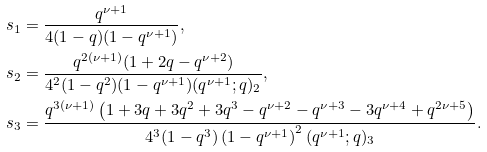Convert formula to latex. <formula><loc_0><loc_0><loc_500><loc_500>s _ { 1 } & = \frac { q ^ { \nu + 1 } } { 4 ( 1 - q ) ( 1 - q ^ { \nu + 1 } ) } , \\ s _ { 2 } & = \frac { q ^ { 2 ( \nu + 1 ) } ( 1 + 2 q - q ^ { \nu + 2 } ) } { 4 ^ { 2 } ( 1 - q ^ { 2 } ) ( 1 - q ^ { \nu + 1 } ) ( q ^ { \nu + 1 } ; q ) _ { 2 } } , \\ s _ { 3 } & = \frac { q ^ { 3 ( \nu + 1 ) } \left ( 1 + 3 q + 3 q ^ { 2 } + 3 q ^ { 3 } - q ^ { \nu + 2 } - q ^ { \nu + 3 } - 3 q ^ { \nu + 4 } + q ^ { 2 \nu + 5 } \right ) } { 4 ^ { 3 } ( 1 - q ^ { 3 } ) \left ( 1 - q ^ { \nu + 1 } \right ) ^ { 2 } ( q ^ { \nu + 1 } ; q ) _ { 3 } } .</formula> 